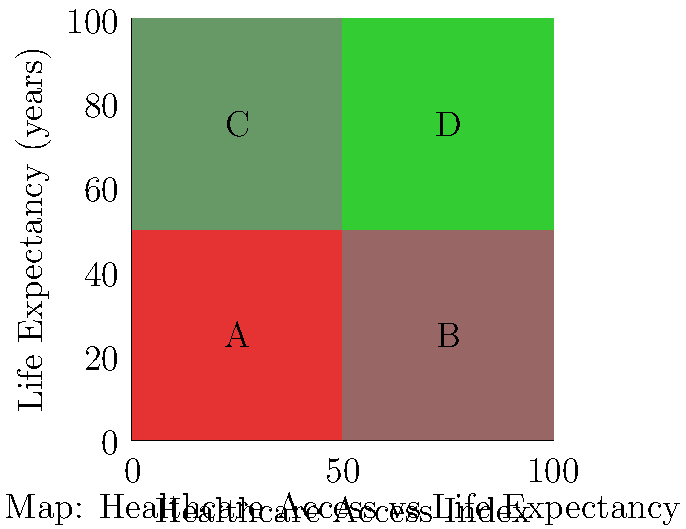Based on the map showing the relationship between healthcare access and life expectancy in different regions, which region is likely to have the highest income inequality and require the most intensive social work intervention? To answer this question, we need to analyze the map and interpret the relationship between healthcare access and life expectancy:

1. The x-axis represents the Healthcare Access Index, increasing from left to right.
2. The y-axis represents Life Expectancy, increasing from bottom to top.
3. The colors of the regions indicate the combined effect of these two factors:
   - Darker red indicates lower healthcare access and lower life expectancy
   - Darker green indicates higher healthcare access and higher life expectancy

4. Analyzing each region:
   A (bottom-left): Lowest healthcare access and lowest life expectancy
   B (bottom-right): High healthcare access but low life expectancy
   C (top-left): Low healthcare access but high life expectancy
   D (top-right): Highest healthcare access and highest life expectancy

5. Region A has the worst combination of low healthcare access and low life expectancy, indicating significant health disparities.

6. In social work, areas with the greatest disparities often correlate with higher income inequality and require more intensive intervention.

Therefore, Region A is likely to have the highest income inequality and require the most intensive social work intervention due to its poor healthcare access and low life expectancy.
Answer: Region A 